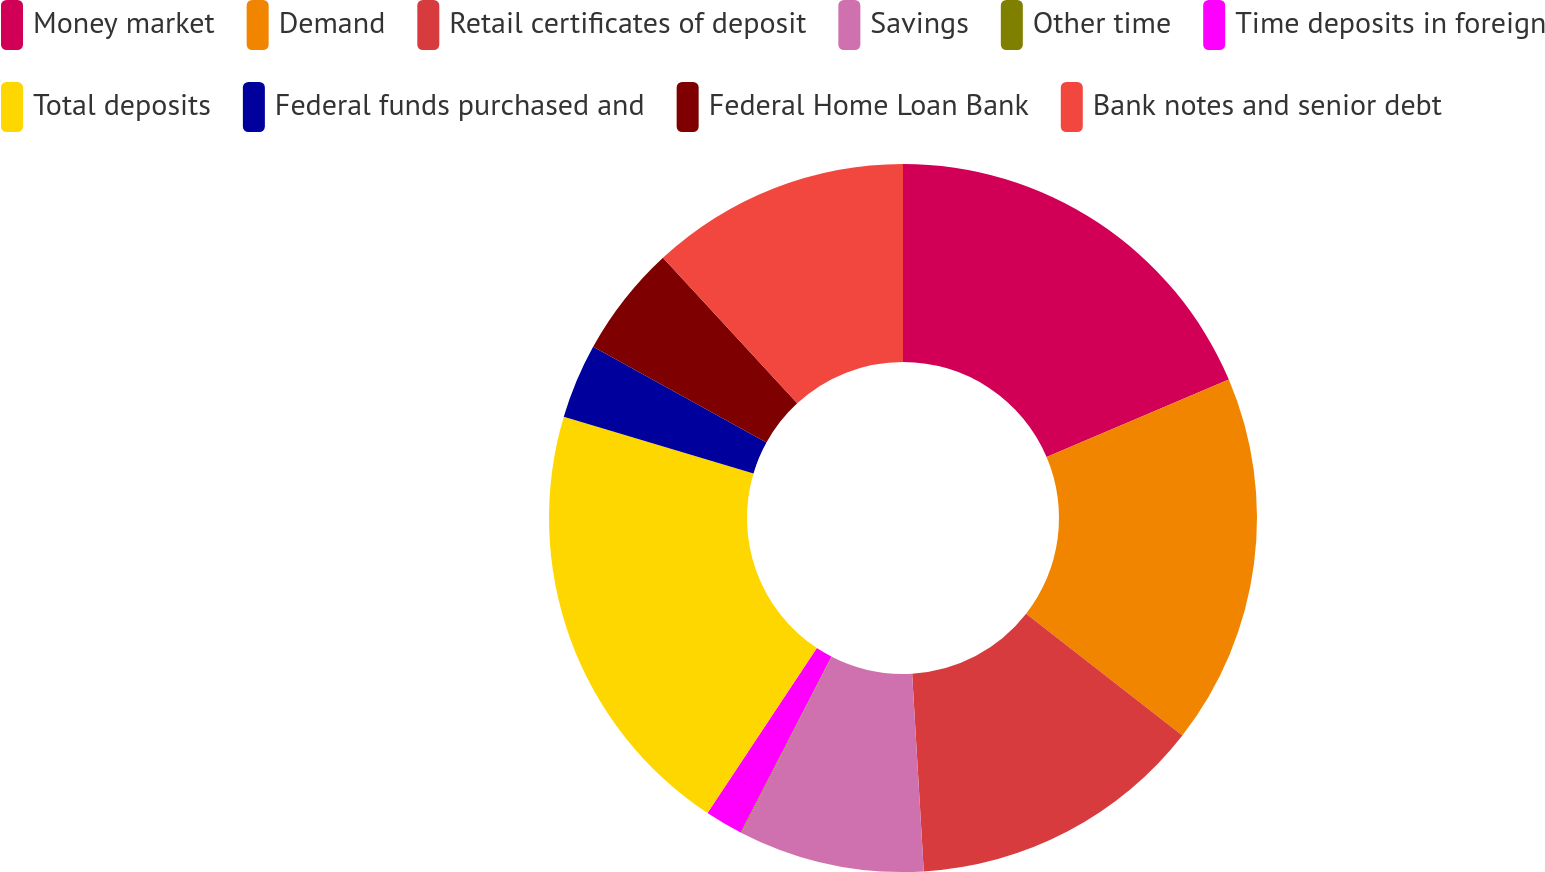Convert chart to OTSL. <chart><loc_0><loc_0><loc_500><loc_500><pie_chart><fcel>Money market<fcel>Demand<fcel>Retail certificates of deposit<fcel>Savings<fcel>Other time<fcel>Time deposits in foreign<fcel>Total deposits<fcel>Federal funds purchased and<fcel>Federal Home Loan Bank<fcel>Bank notes and senior debt<nl><fcel>18.61%<fcel>16.92%<fcel>13.54%<fcel>8.48%<fcel>0.04%<fcel>1.73%<fcel>20.3%<fcel>3.42%<fcel>5.11%<fcel>11.86%<nl></chart> 